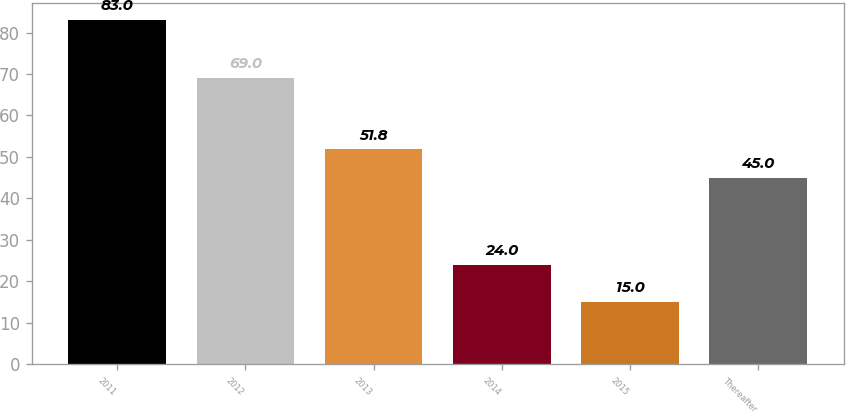Convert chart to OTSL. <chart><loc_0><loc_0><loc_500><loc_500><bar_chart><fcel>2011<fcel>2012<fcel>2013<fcel>2014<fcel>2015<fcel>Thereafter<nl><fcel>83<fcel>69<fcel>51.8<fcel>24<fcel>15<fcel>45<nl></chart> 